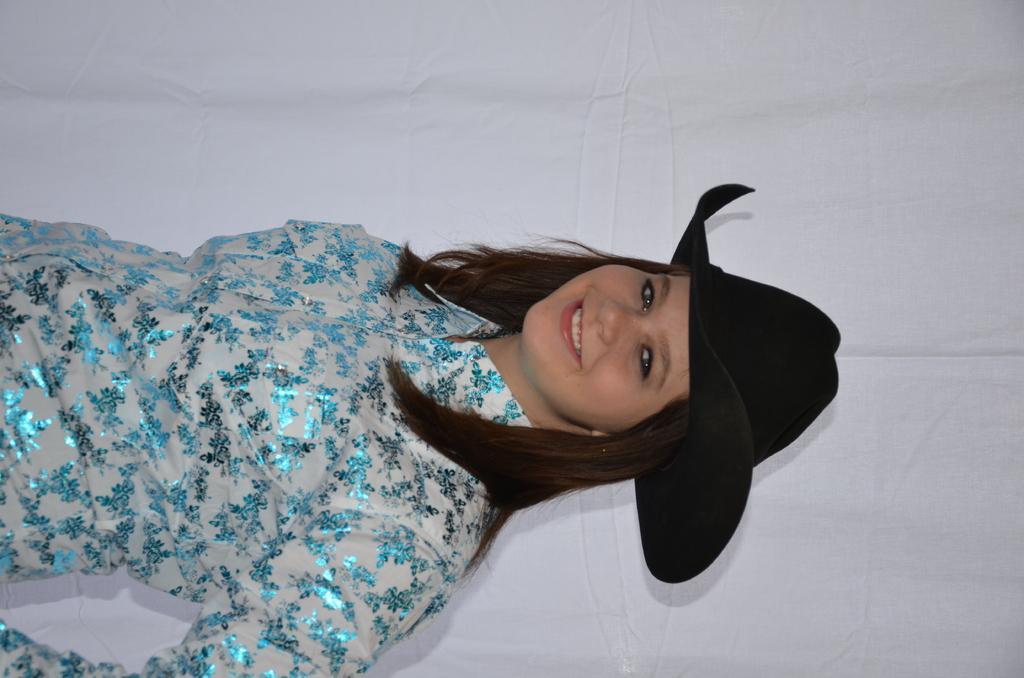Describe this image in one or two sentences. In this picture we can see a woman with the black hat and she is smiling. Behind the woman there is the white background. 